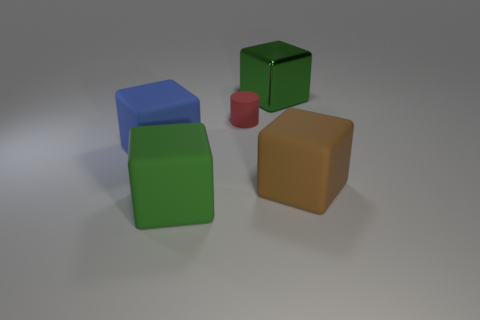Subtract all gray blocks. Subtract all blue cylinders. How many blocks are left? 4 Add 5 gray things. How many objects exist? 10 Subtract all cylinders. How many objects are left? 4 Subtract all tiny purple metallic things. Subtract all tiny matte things. How many objects are left? 4 Add 4 green metal blocks. How many green metal blocks are left? 5 Add 1 big brown rubber objects. How many big brown rubber objects exist? 2 Subtract 1 blue blocks. How many objects are left? 4 